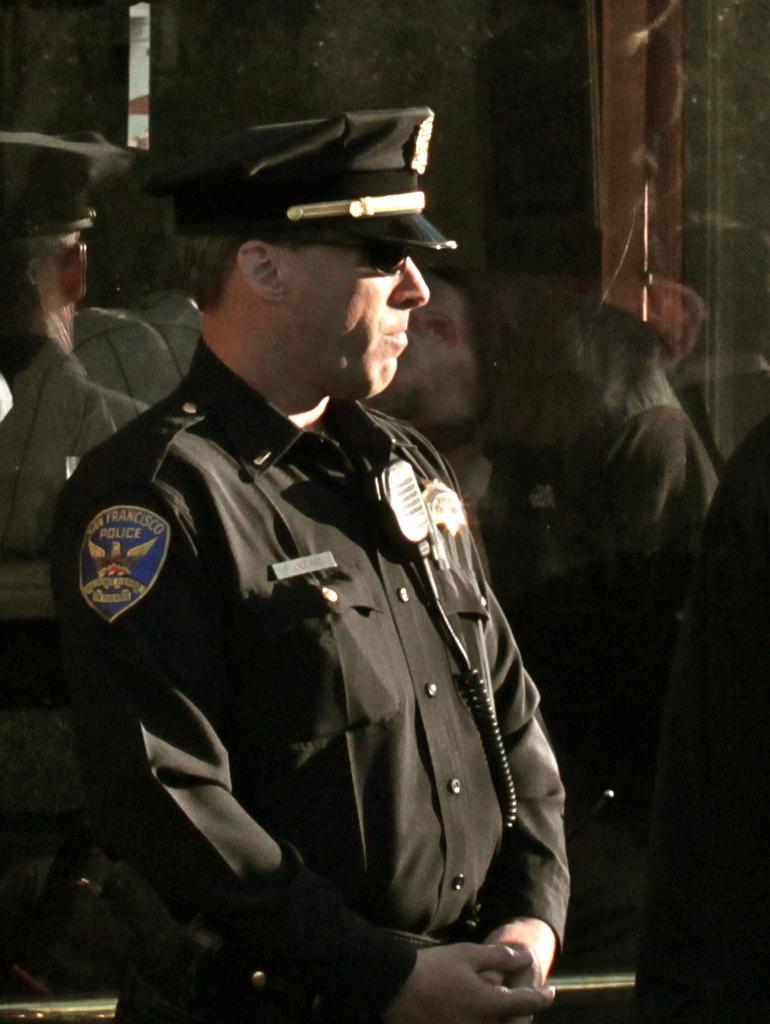Describe this image in one or two sentences. In the center of this picture there is a person wearing a uniform and standing. In the background there is a glass and we can see the reflection of some persons on the glass. 